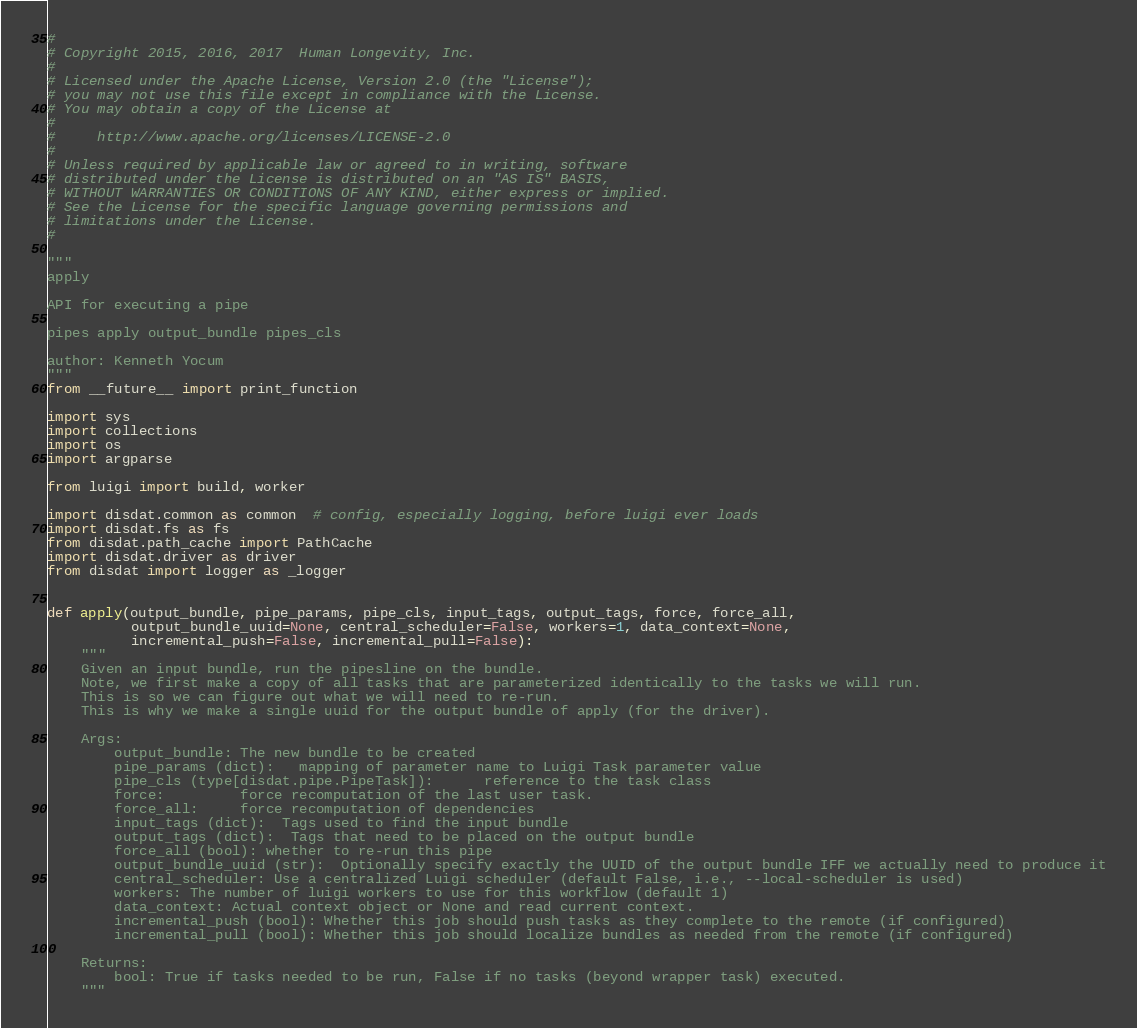<code> <loc_0><loc_0><loc_500><loc_500><_Python_>#
# Copyright 2015, 2016, 2017  Human Longevity, Inc.
#
# Licensed under the Apache License, Version 2.0 (the "License");
# you may not use this file except in compliance with the License.
# You may obtain a copy of the License at
#
#     http://www.apache.org/licenses/LICENSE-2.0
#
# Unless required by applicable law or agreed to in writing, software
# distributed under the License is distributed on an "AS IS" BASIS,
# WITHOUT WARRANTIES OR CONDITIONS OF ANY KIND, either express or implied.
# See the License for the specific language governing permissions and
# limitations under the License.
#

"""
apply

API for executing a pipe

pipes apply output_bundle pipes_cls

author: Kenneth Yocum
"""
from __future__ import print_function

import sys
import collections
import os
import argparse

from luigi import build, worker

import disdat.common as common  # config, especially logging, before luigi ever loads
import disdat.fs as fs
from disdat.path_cache import PathCache
import disdat.driver as driver
from disdat import logger as _logger


def apply(output_bundle, pipe_params, pipe_cls, input_tags, output_tags, force, force_all,
          output_bundle_uuid=None, central_scheduler=False, workers=1, data_context=None,
          incremental_push=False, incremental_pull=False):
    """
    Given an input bundle, run the pipesline on the bundle.
    Note, we first make a copy of all tasks that are parameterized identically to the tasks we will run.
    This is so we can figure out what we will need to re-run.
    This is why we make a single uuid for the output bundle of apply (for the driver).

    Args:
        output_bundle: The new bundle to be created
        pipe_params (dict):   mapping of parameter name to Luigi Task parameter value
        pipe_cls (type[disdat.pipe.PipeTask]):      reference to the task class
        force:         force recomputation of the last user task.
        force_all:     force recomputation of dependencies
        input_tags (dict):  Tags used to find the input bundle
        output_tags (dict):  Tags that need to be placed on the output bundle
        force_all (bool): whether to re-run this pipe
        output_bundle_uuid (str):  Optionally specify exactly the UUID of the output bundle IFF we actually need to produce it
        central_scheduler: Use a centralized Luigi scheduler (default False, i.e., --local-scheduler is used)
        workers: The number of luigi workers to use for this workflow (default 1)
        data_context: Actual context object or None and read current context.
        incremental_push (bool): Whether this job should push tasks as they complete to the remote (if configured)
        incremental_pull (bool): Whether this job should localize bundles as needed from the remote (if configured)

    Returns:
        bool: True if tasks needed to be run, False if no tasks (beyond wrapper task) executed.
    """
</code> 